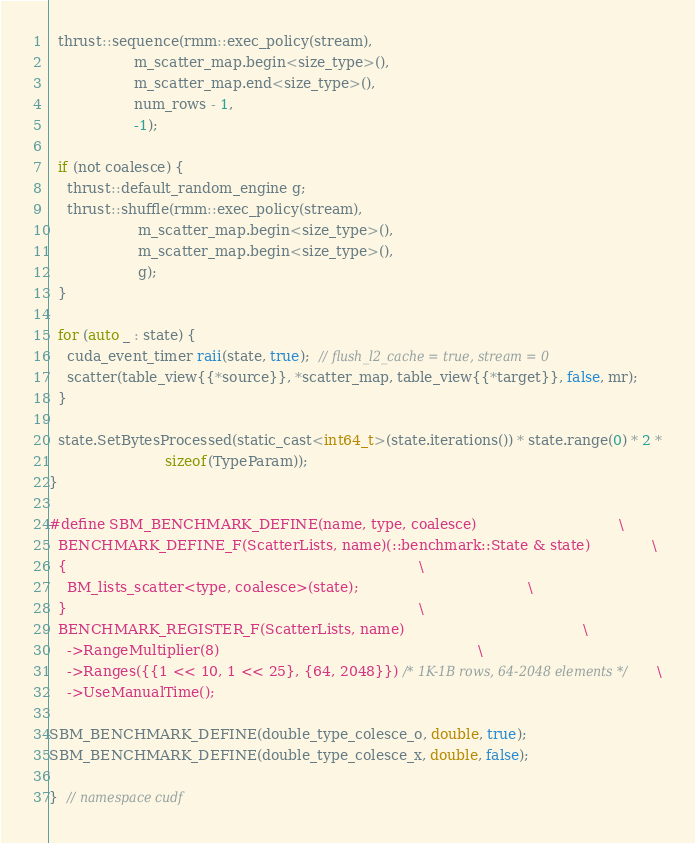<code> <loc_0><loc_0><loc_500><loc_500><_Cuda_>  thrust::sequence(rmm::exec_policy(stream),
                   m_scatter_map.begin<size_type>(),
                   m_scatter_map.end<size_type>(),
                   num_rows - 1,
                   -1);

  if (not coalesce) {
    thrust::default_random_engine g;
    thrust::shuffle(rmm::exec_policy(stream),
                    m_scatter_map.begin<size_type>(),
                    m_scatter_map.begin<size_type>(),
                    g);
  }

  for (auto _ : state) {
    cuda_event_timer raii(state, true);  // flush_l2_cache = true, stream = 0
    scatter(table_view{{*source}}, *scatter_map, table_view{{*target}}, false, mr);
  }

  state.SetBytesProcessed(static_cast<int64_t>(state.iterations()) * state.range(0) * 2 *
                          sizeof(TypeParam));
}

#define SBM_BENCHMARK_DEFINE(name, type, coalesce)                                \
  BENCHMARK_DEFINE_F(ScatterLists, name)(::benchmark::State & state)              \
  {                                                                               \
    BM_lists_scatter<type, coalesce>(state);                                      \
  }                                                                               \
  BENCHMARK_REGISTER_F(ScatterLists, name)                                        \
    ->RangeMultiplier(8)                                                          \
    ->Ranges({{1 << 10, 1 << 25}, {64, 2048}}) /* 1K-1B rows, 64-2048 elements */ \
    ->UseManualTime();

SBM_BENCHMARK_DEFINE(double_type_colesce_o, double, true);
SBM_BENCHMARK_DEFINE(double_type_colesce_x, double, false);

}  // namespace cudf
</code> 